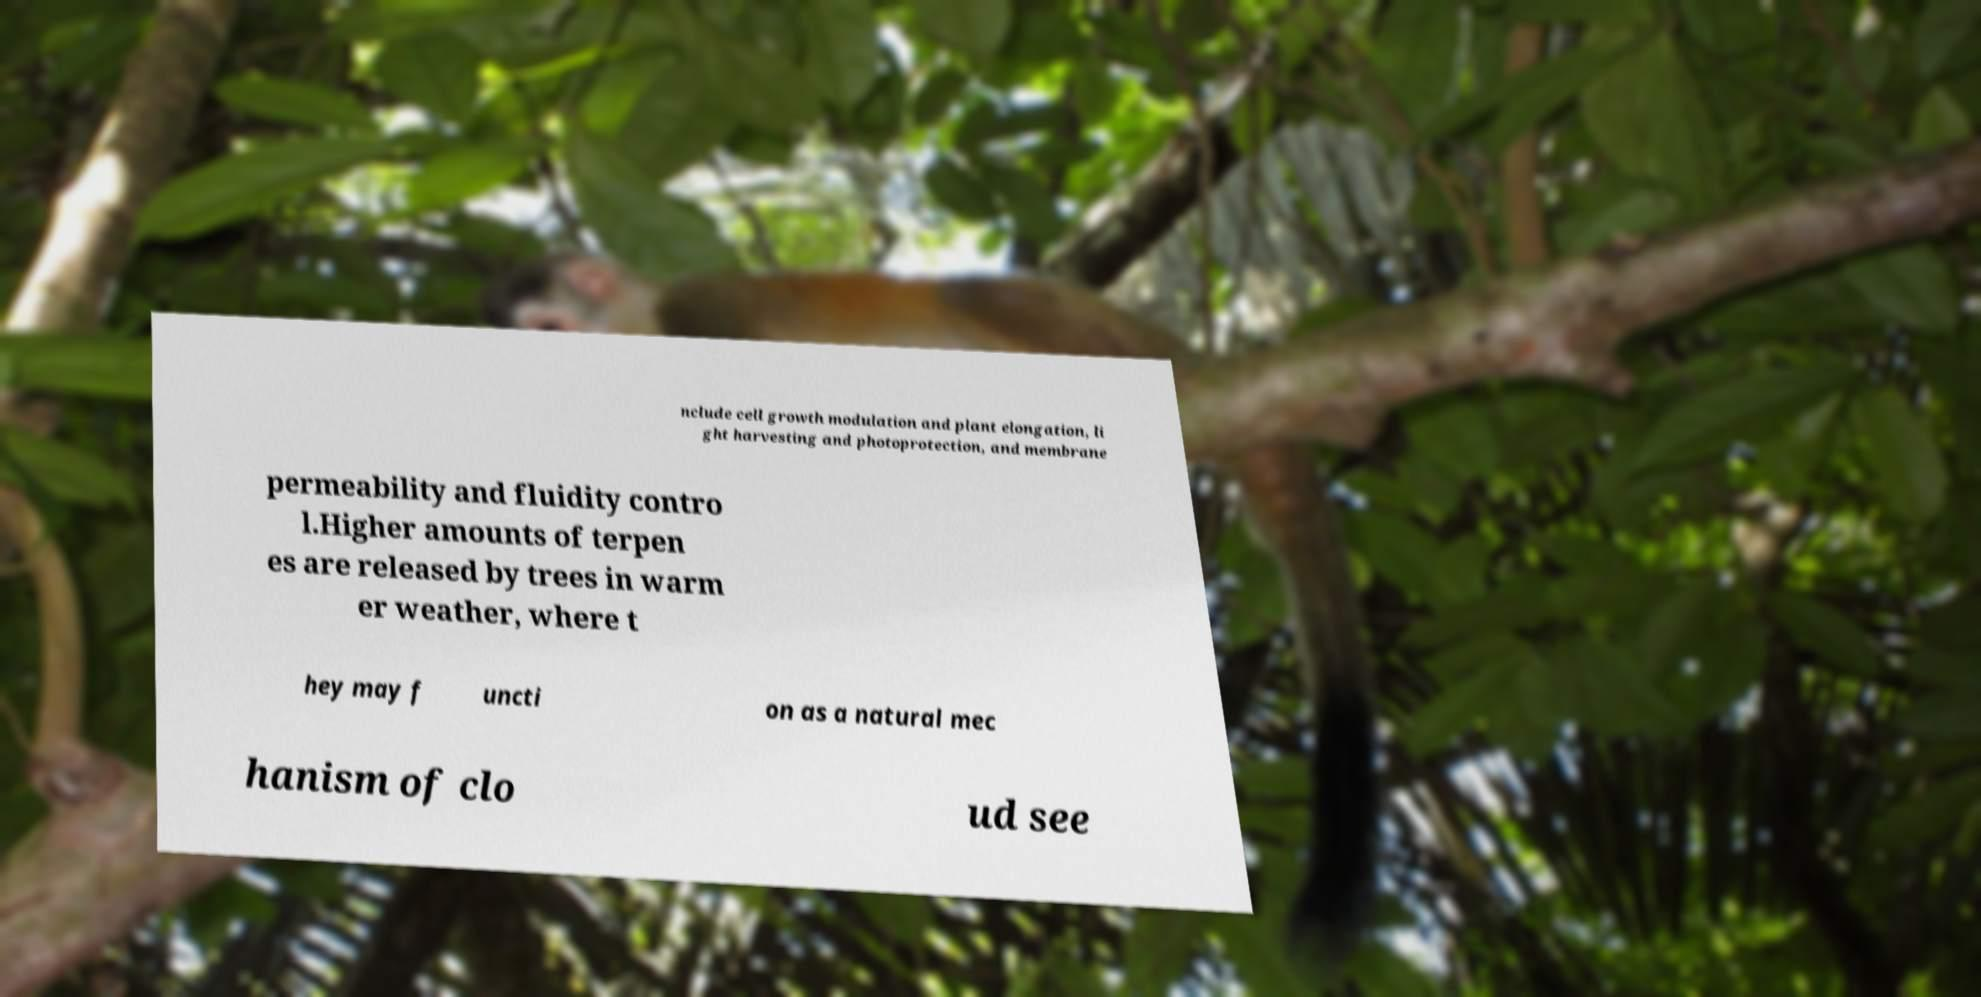Could you assist in decoding the text presented in this image and type it out clearly? nclude cell growth modulation and plant elongation, li ght harvesting and photoprotection, and membrane permeability and fluidity contro l.Higher amounts of terpen es are released by trees in warm er weather, where t hey may f uncti on as a natural mec hanism of clo ud see 